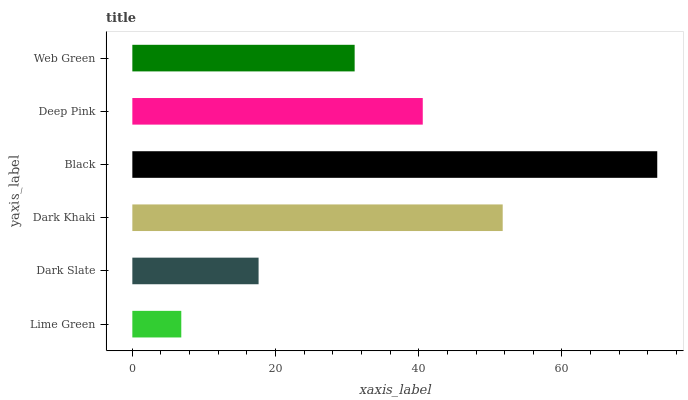Is Lime Green the minimum?
Answer yes or no. Yes. Is Black the maximum?
Answer yes or no. Yes. Is Dark Slate the minimum?
Answer yes or no. No. Is Dark Slate the maximum?
Answer yes or no. No. Is Dark Slate greater than Lime Green?
Answer yes or no. Yes. Is Lime Green less than Dark Slate?
Answer yes or no. Yes. Is Lime Green greater than Dark Slate?
Answer yes or no. No. Is Dark Slate less than Lime Green?
Answer yes or no. No. Is Deep Pink the high median?
Answer yes or no. Yes. Is Web Green the low median?
Answer yes or no. Yes. Is Black the high median?
Answer yes or no. No. Is Dark Khaki the low median?
Answer yes or no. No. 